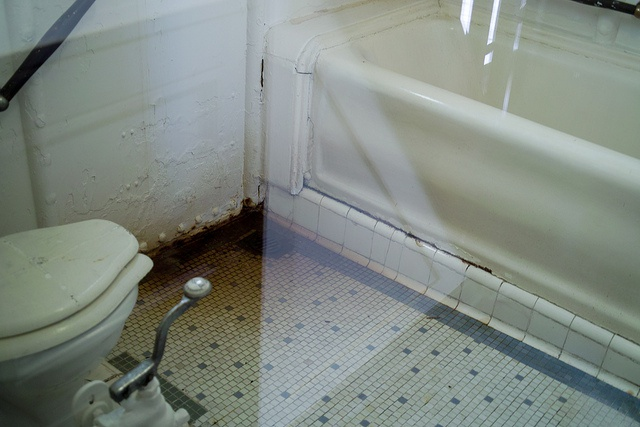Describe the objects in this image and their specific colors. I can see toilet in gray, darkgray, and black tones and sink in gray, darkgray, and lightgray tones in this image. 